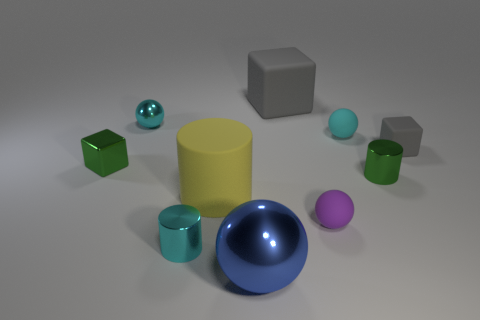Subtract all brown blocks. How many cyan balls are left? 2 Subtract all matte blocks. How many blocks are left? 1 Subtract all purple spheres. How many spheres are left? 3 Subtract all brown cylinders. Subtract all purple blocks. How many cylinders are left? 3 Subtract all cubes. How many objects are left? 7 Add 8 green things. How many green things are left? 10 Add 10 small brown shiny things. How many small brown shiny things exist? 10 Subtract 0 red cubes. How many objects are left? 10 Subtract all balls. Subtract all gray things. How many objects are left? 4 